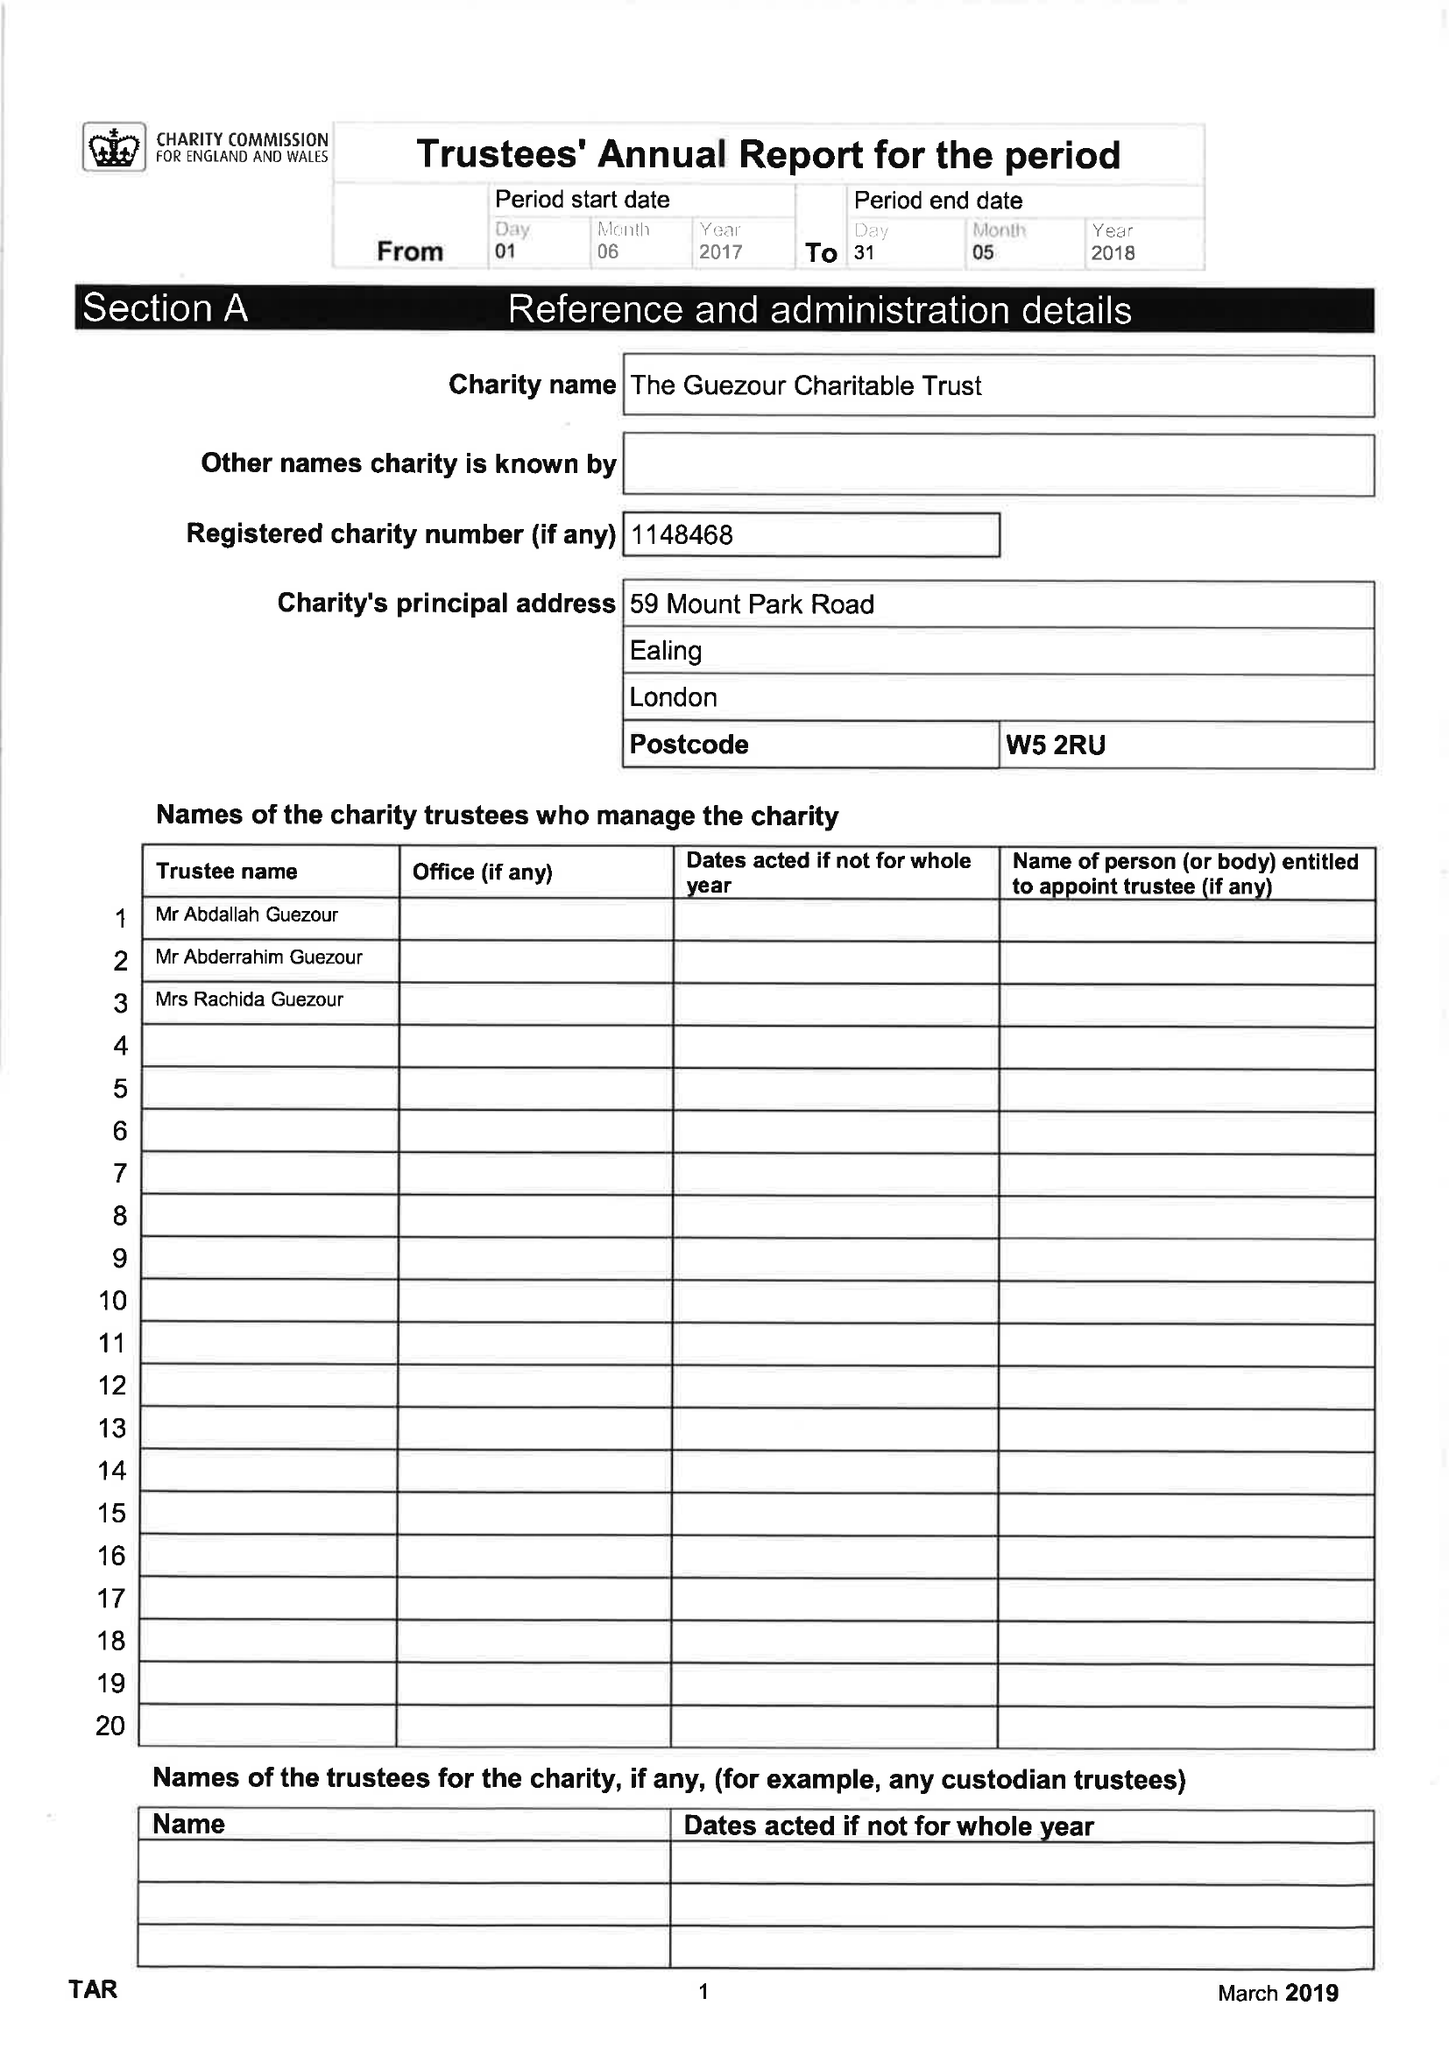What is the value for the address__street_line?
Answer the question using a single word or phrase. 59 MOUNT PARK ROAD 